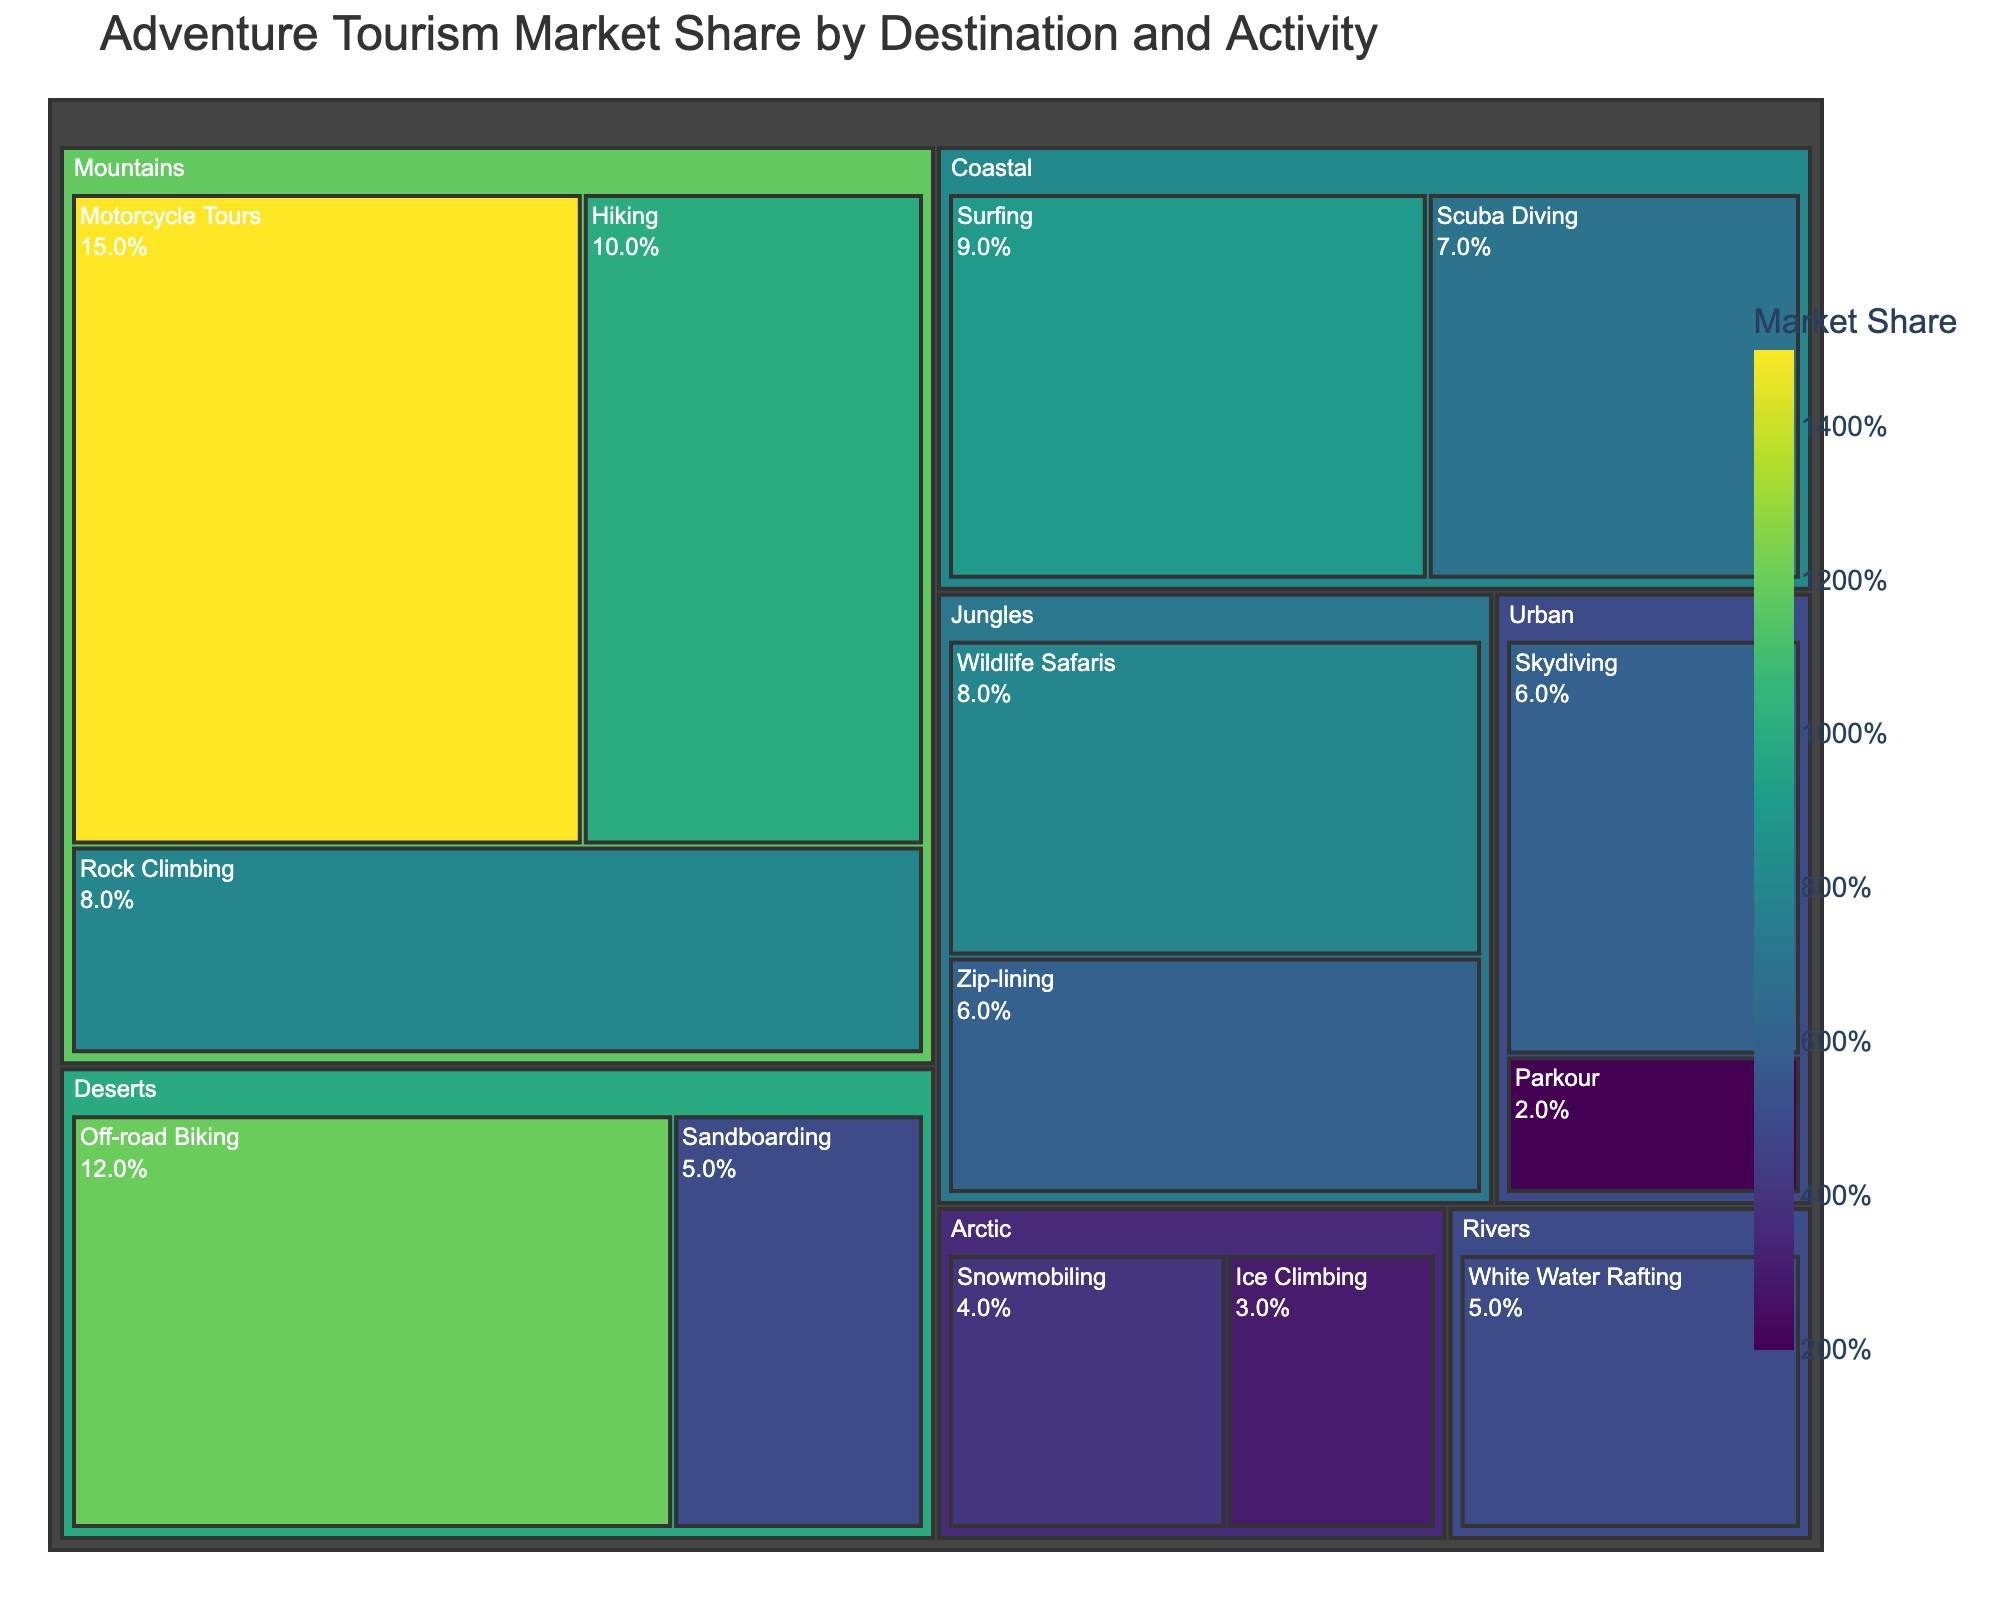Which destination type has the highest market share for adventure tourism? Look at the largest section in the treemap under the 'destination' category. The 'Mountains' section is the largest, indicating it has the highest market share.
Answer: Mountains What is the market share of Motorcycle Tours in the Mountains destination? Find the sub-section labeled 'Motorcycle Tours' under 'Mountains'. The market share is indicated inside the label.
Answer: 15% Compare the market share between Scuba Diving and Surfing in Coastal destinations. Which one is higher? Locate the sections for 'Scuba Diving' and 'Surfing' under the 'Coastal' category. Compare their values; 'Surfing' (9%) is higher than 'Scuba Diving' (7%).
Answer: Surfing What is the combined market share of Hiking and Rock Climbing in the Mountains? Sum the market shares of Hiking (10%) and Rock Climbing (8%) in the Mountains section.
Answer: 18% How much higher is the market share of Off-road Biking in Deserts compared to Sandboarding in Deserts? Subtract the market share of Sandboarding (5%) from Off-road Biking (12%) in the Deserts section.
Answer: 7% Which activity has the lowest market share, and in which destination is it found? Look for the smallest individual section in the treemap. 'Ice Climbing' in the 'Arctic' is the smallest.
Answer: Ice Climbing in Arctic What is the total market share for all activities in the Urban destination? Sum the market shares of 'Parkour' (2%) and 'Skydiving' (6%) in the Urban section.
Answer: 8% How does the market share of Zip-lining in Jungles compare to White Water Rafting in Rivers? Compare the sections labeled 'Zip-lining' in the Jungles (6%) and 'White Water Rafting' in the Rivers (5%). 'Zip-lining' has a higher market share.
Answer: Zip-lining What is the average market share of activities in the Arctic destination? Sum the market shares of Snowmobiling (4%) and Ice Climbing (3%) and divide by 2: (4% + 3%) / 2.
Answer: 3.5% If you combine the market shares of all activities in the Coastal and Jungles destinations, what is the total market share? Add the market shares of all activities in Coastal (Surfing 9% + Scuba Diving 7%) and Jungles (Zip-lining 6% + Wildlife Safaris 8%): (9% + 7%) + (6% + 8%).
Answer: 30% 